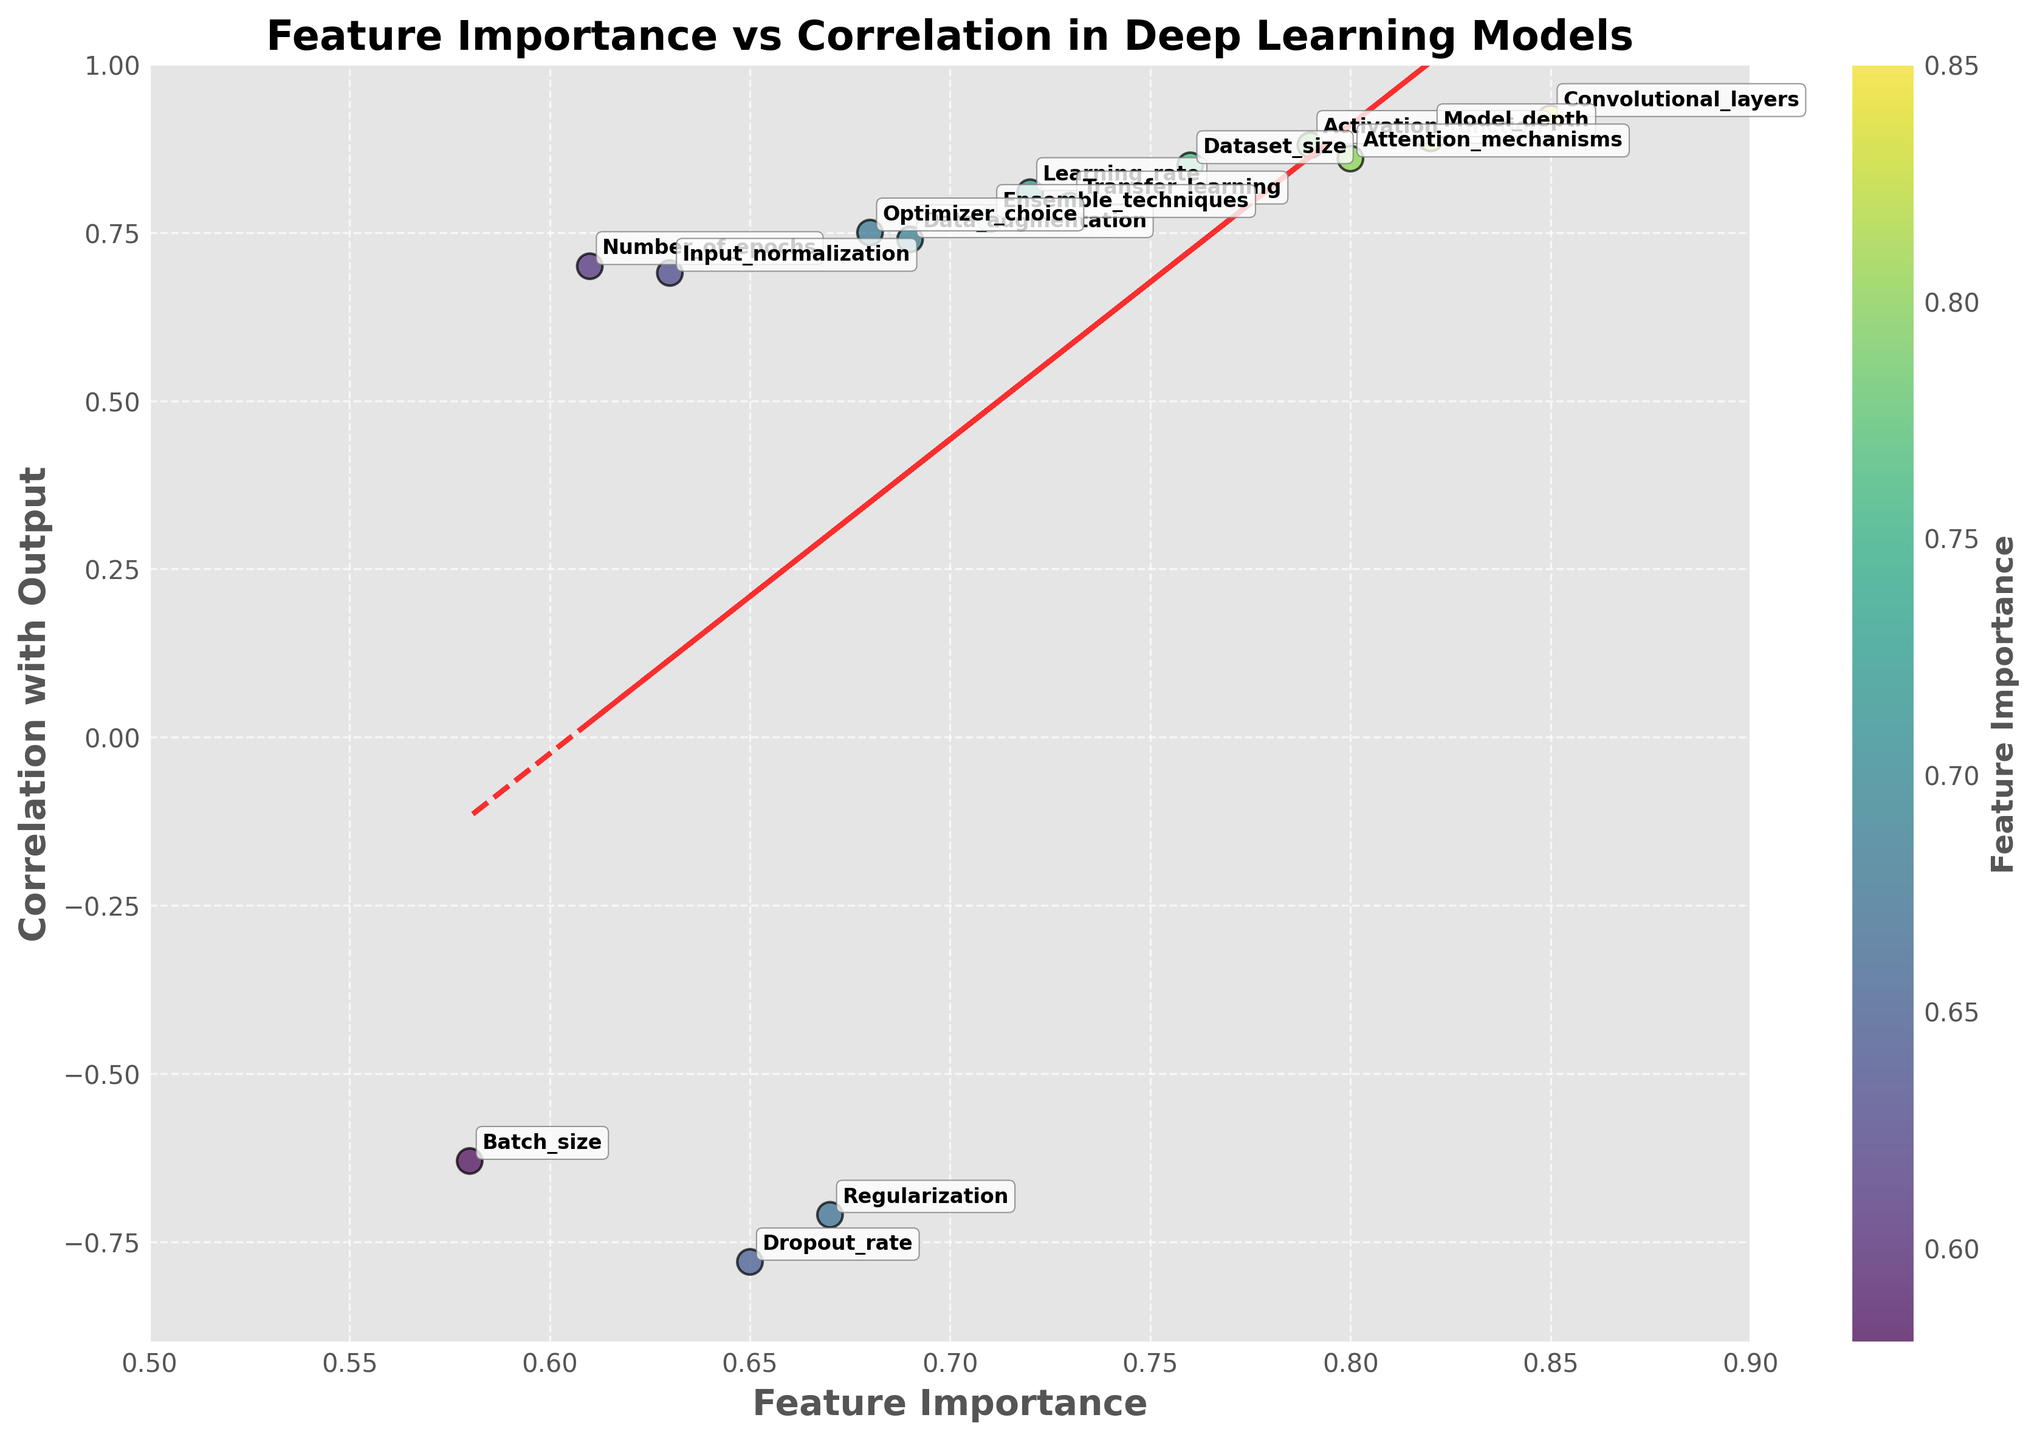What is the title of the plot? By looking at the top of the figure, the title is clearly visible.
Answer: Feature Importance vs Correlation in Deep Learning Models Which feature has the highest correlation with the output? Scan through the figure to identify the data point which lies furthest along the y-axis.
Answer: Convolutional_layers What is the approximate correlation for the feature 'Dropout_rate'? Locate the 'Dropout_rate' label on the plot and read its y-axis value.
Answer: -0.78 What is the relationship between feature importance and correlation with the output? By observing the trend line added to the plot, we can see whether there is a positive or negative correlation overall.
Answer: Positive Which feature has both high importance and high correlation with the output? Look for the data points that are positioned towards the top-right corner of the plot and identify the corresponding label.
Answer: Convolutional_layers How many features have a negative correlation with the output? Count the data points that fall below the zero line on the y-axis.
Answer: 3 Do 'Model_depth' and 'Batch_size' have similar feature importance? Compare the x-axis values of 'Model_depth' and 'Batch_size'.
Answer: No Which features are clustered close together in terms of both importance and correlation? Observe data points that are grouped closely in the plot, both in terms of x (importance) and y (correlation) axes.
Answer: Transfer_learning and Learning_rate Is there any feature with low importance but high correlation? Identify any points that lie high on the y-axis but towards the left on the x-axis.
Answer: No What is the range of feature importance values shown in the plot? Observe and note the minimum and maximum x-values in the plot.
Answer: 0.58 to 0.85 